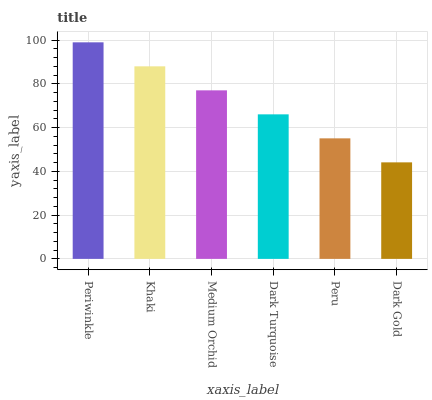Is Dark Gold the minimum?
Answer yes or no. Yes. Is Periwinkle the maximum?
Answer yes or no. Yes. Is Khaki the minimum?
Answer yes or no. No. Is Khaki the maximum?
Answer yes or no. No. Is Periwinkle greater than Khaki?
Answer yes or no. Yes. Is Khaki less than Periwinkle?
Answer yes or no. Yes. Is Khaki greater than Periwinkle?
Answer yes or no. No. Is Periwinkle less than Khaki?
Answer yes or no. No. Is Medium Orchid the high median?
Answer yes or no. Yes. Is Dark Turquoise the low median?
Answer yes or no. Yes. Is Peru the high median?
Answer yes or no. No. Is Khaki the low median?
Answer yes or no. No. 